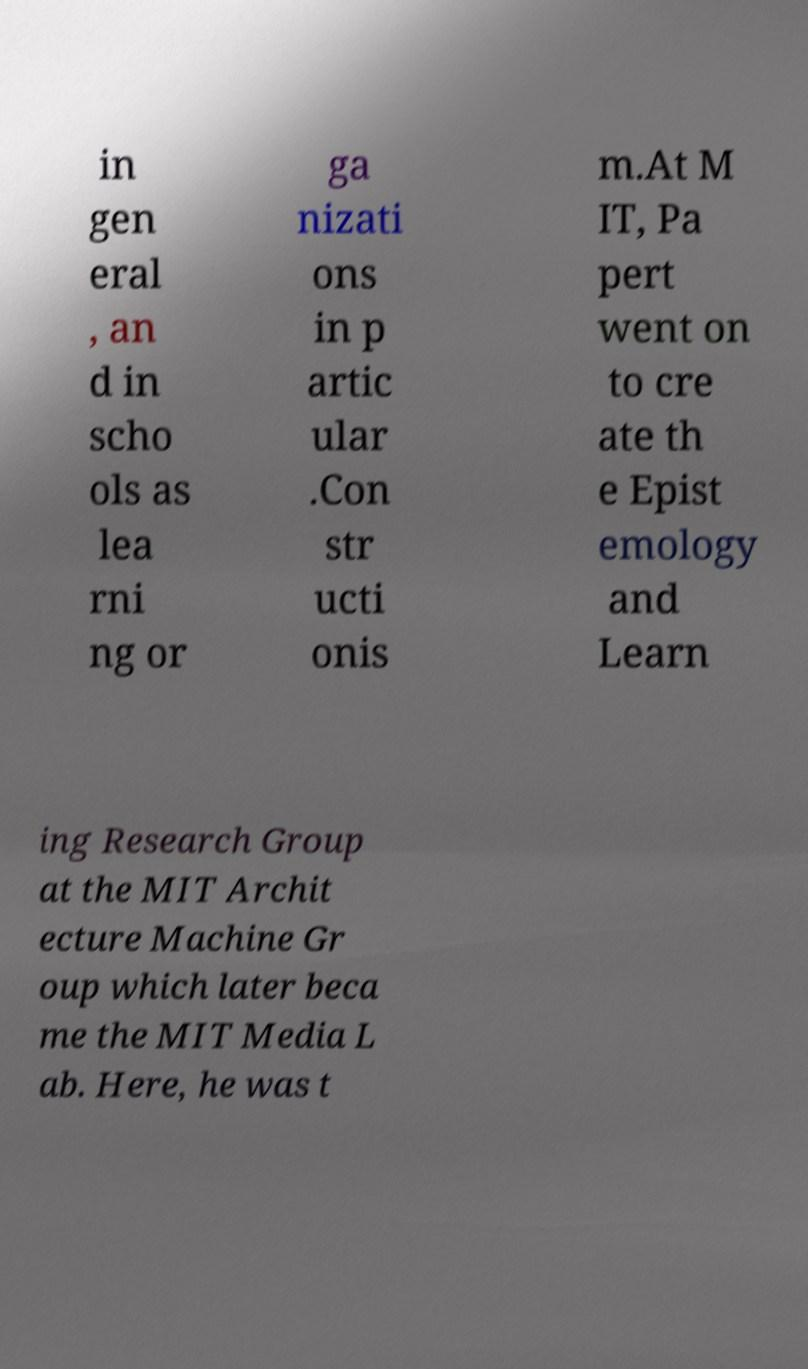Please identify and transcribe the text found in this image. in gen eral , an d in scho ols as lea rni ng or ga nizati ons in p artic ular .Con str ucti onis m.At M IT, Pa pert went on to cre ate th e Epist emology and Learn ing Research Group at the MIT Archit ecture Machine Gr oup which later beca me the MIT Media L ab. Here, he was t 